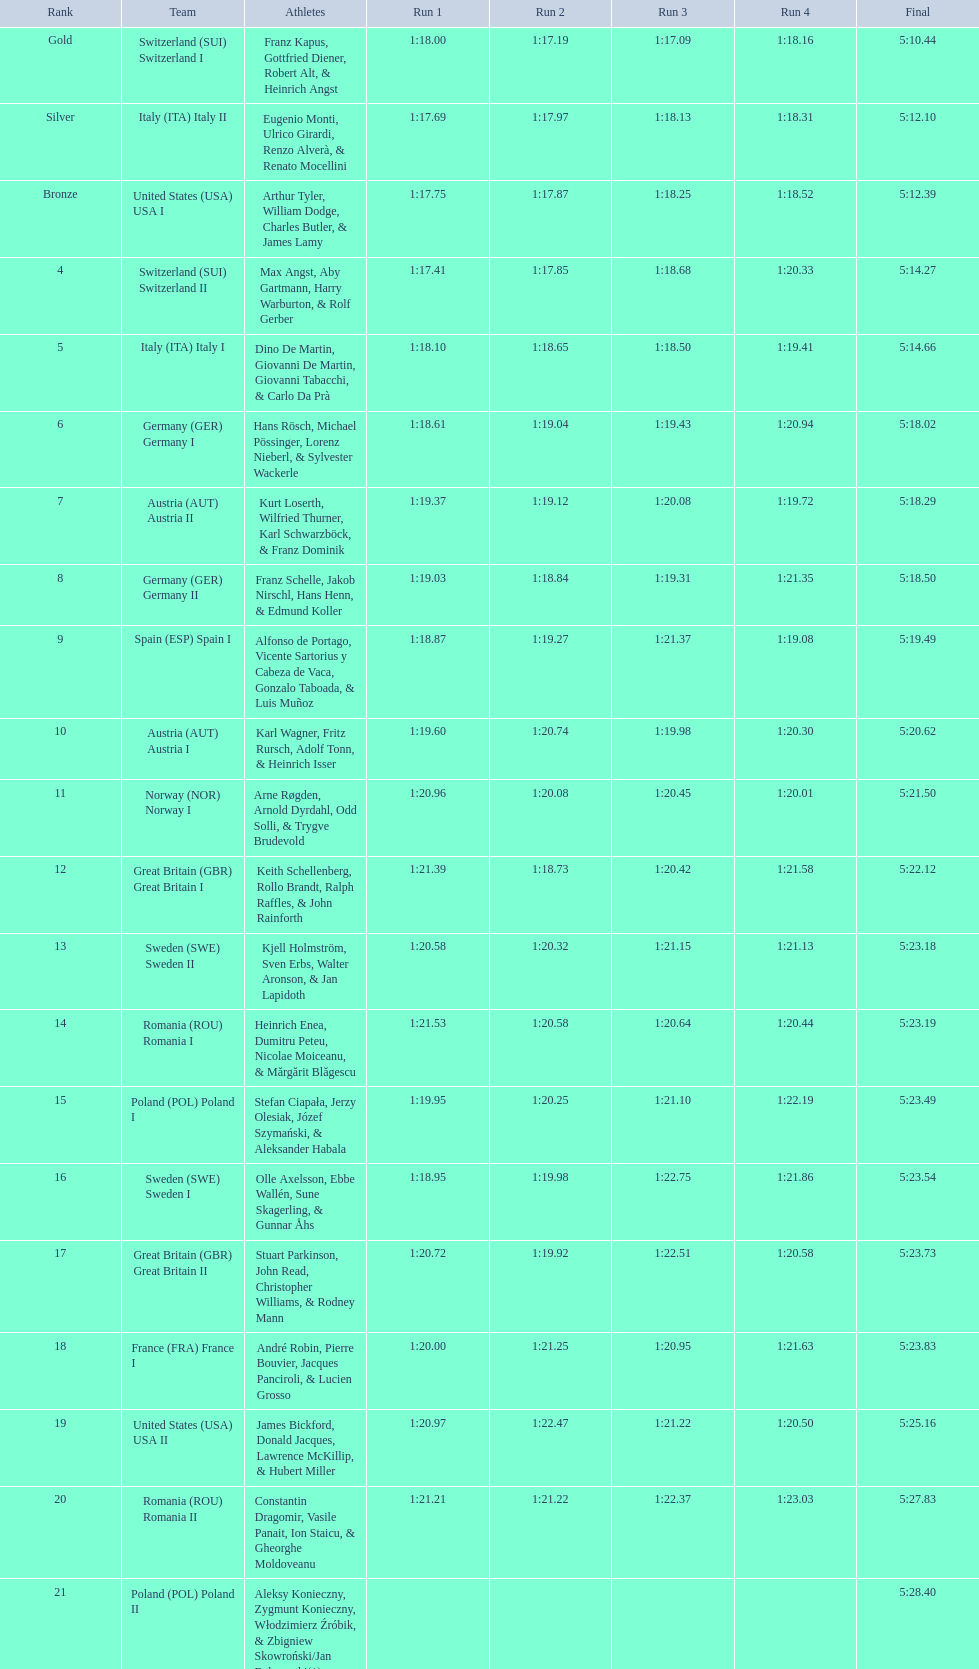Who achieved a greater position, italy or germany? Italy. 